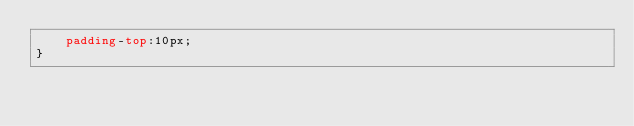<code> <loc_0><loc_0><loc_500><loc_500><_CSS_>    padding-top:10px;
}</code> 